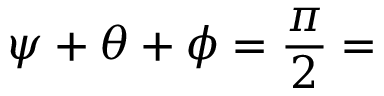<formula> <loc_0><loc_0><loc_500><loc_500>\psi + \theta + \phi = { \frac { \pi } { 2 } } =</formula> 